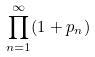<formula> <loc_0><loc_0><loc_500><loc_500>\prod _ { n = 1 } ^ { \infty } ( 1 + p _ { n } )</formula> 